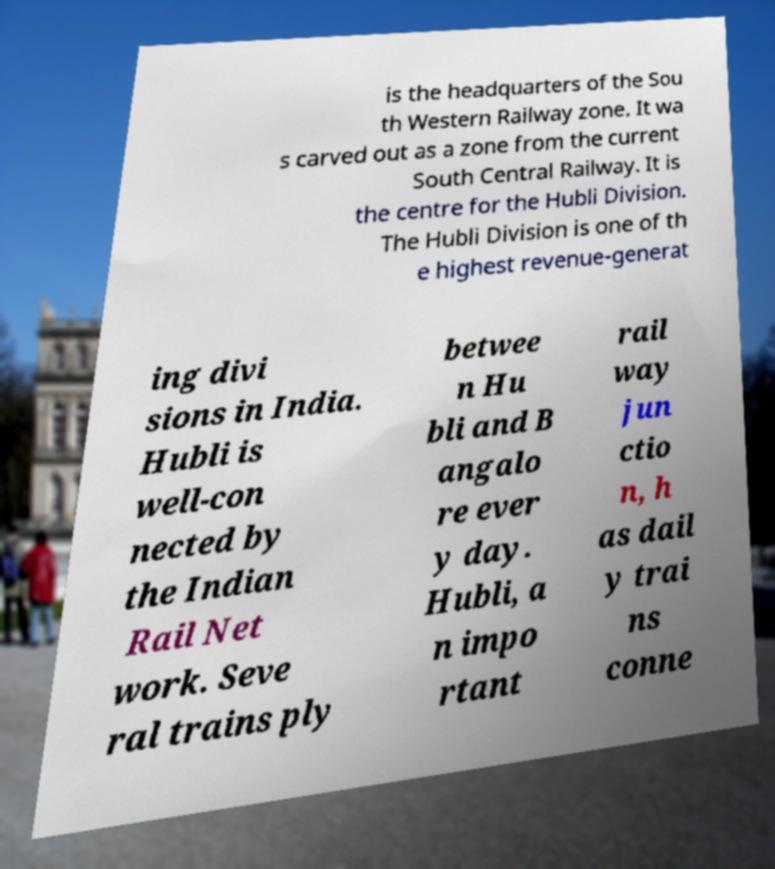Can you accurately transcribe the text from the provided image for me? is the headquarters of the Sou th Western Railway zone. It wa s carved out as a zone from the current South Central Railway. It is the centre for the Hubli Division. The Hubli Division is one of th e highest revenue-generat ing divi sions in India. Hubli is well-con nected by the Indian Rail Net work. Seve ral trains ply betwee n Hu bli and B angalo re ever y day. Hubli, a n impo rtant rail way jun ctio n, h as dail y trai ns conne 